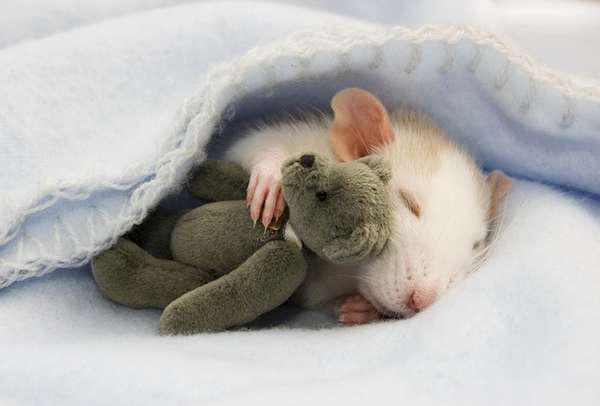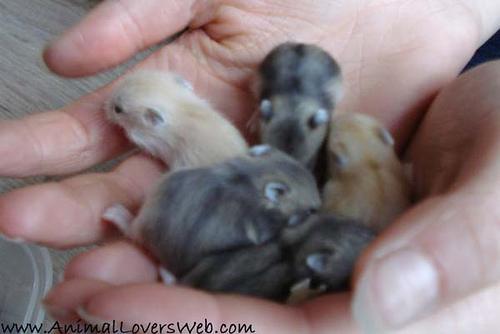The first image is the image on the left, the second image is the image on the right. Given the left and right images, does the statement "Each image shows a hand holding exactly one pet rodent, and each pet rodent is held, but not grasped, in an upturned hand." hold true? Answer yes or no. No. The first image is the image on the left, the second image is the image on the right. For the images displayed, is the sentence "The hamsters are all the same color." factually correct? Answer yes or no. No. 